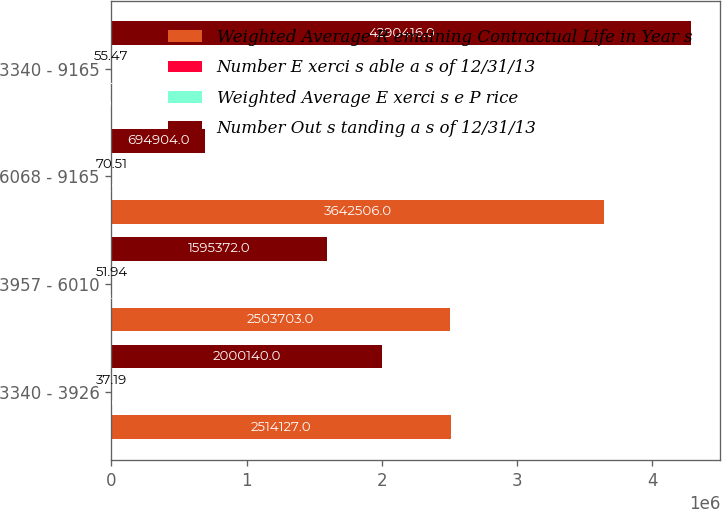Convert chart. <chart><loc_0><loc_0><loc_500><loc_500><stacked_bar_chart><ecel><fcel>3340 - 3926<fcel>3957 - 6010<fcel>6068 - 9165<fcel>3340 - 9165<nl><fcel>Weighted Average R emaining Contractual Life in Year s<fcel>2.51413e+06<fcel>2.5037e+06<fcel>3.64251e+06<fcel>70.51<nl><fcel>Number E xerci s able a s of 12/31/13<fcel>5<fcel>5.1<fcel>7.9<fcel>6.3<nl><fcel>Weighted Average E xerci s e P rice<fcel>37.19<fcel>51.94<fcel>70.51<fcel>55.47<nl><fcel>Number Out s tanding a s of 12/31/13<fcel>2.00014e+06<fcel>1.59537e+06<fcel>694904<fcel>4.29042e+06<nl></chart> 